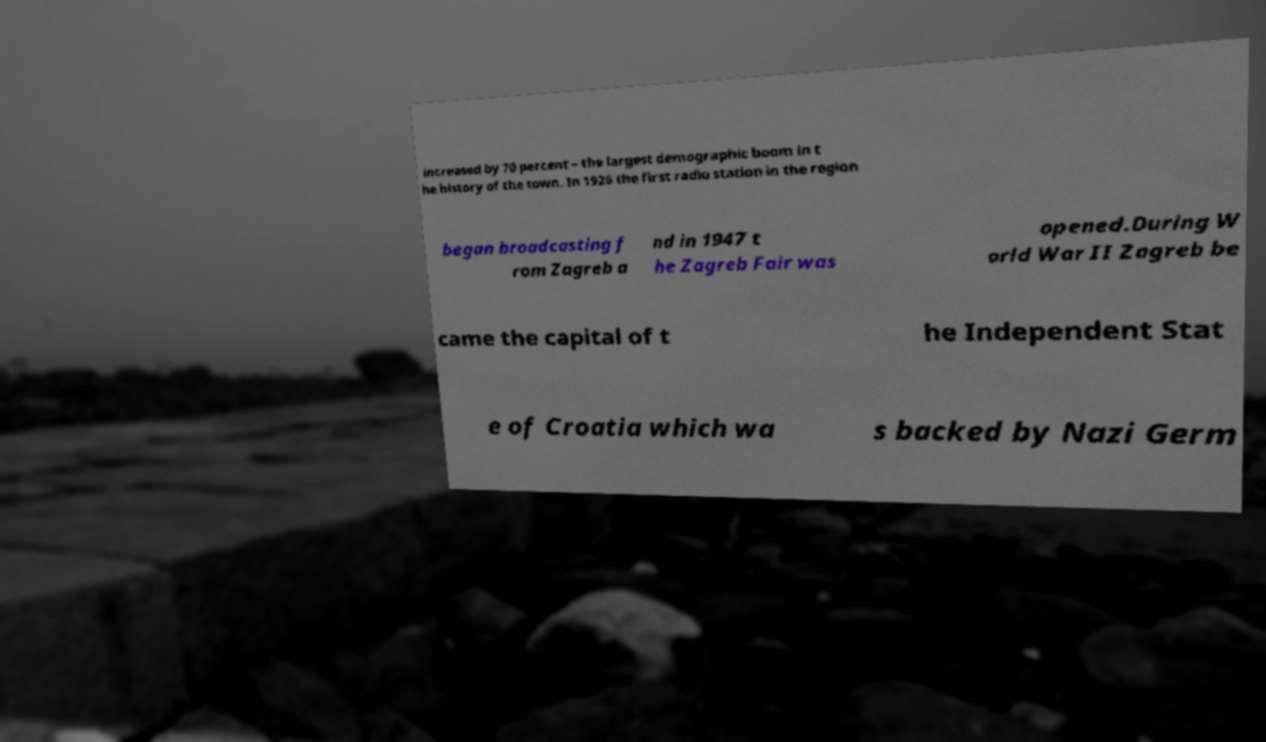There's text embedded in this image that I need extracted. Can you transcribe it verbatim? increased by 70 percent – the largest demographic boom in t he history of the town. In 1926 the first radio station in the region began broadcasting f rom Zagreb a nd in 1947 t he Zagreb Fair was opened.During W orld War II Zagreb be came the capital of t he Independent Stat e of Croatia which wa s backed by Nazi Germ 